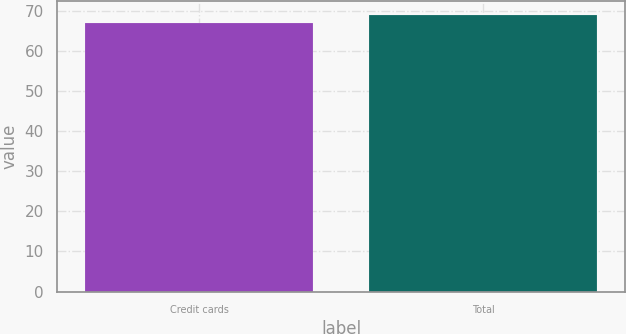Convert chart. <chart><loc_0><loc_0><loc_500><loc_500><bar_chart><fcel>Credit cards<fcel>Total<nl><fcel>67.1<fcel>69.1<nl></chart> 